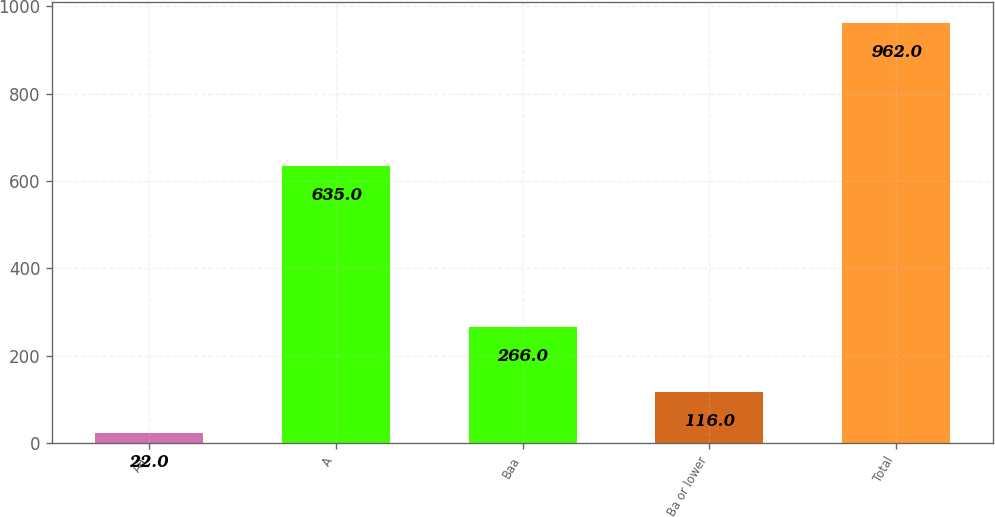Convert chart to OTSL. <chart><loc_0><loc_0><loc_500><loc_500><bar_chart><fcel>Aa<fcel>A<fcel>Baa<fcel>Ba or lower<fcel>Total<nl><fcel>22<fcel>635<fcel>266<fcel>116<fcel>962<nl></chart> 